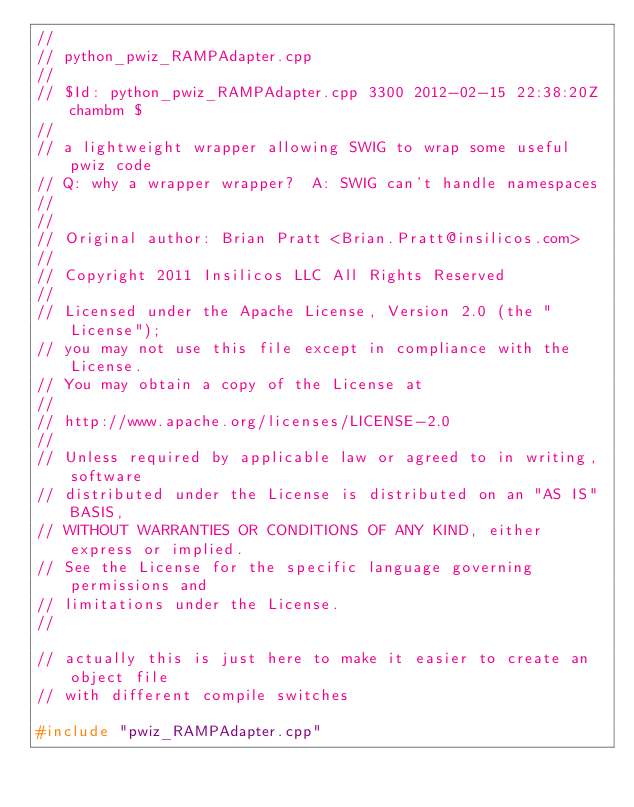<code> <loc_0><loc_0><loc_500><loc_500><_C++_>//
// python_pwiz_RAMPAdapter.cpp
//
// $Id: python_pwiz_RAMPAdapter.cpp 3300 2012-02-15 22:38:20Z chambm $
//
// a lightweight wrapper allowing SWIG to wrap some useful pwiz code
// Q: why a wrapper wrapper?  A: SWIG can't handle namespaces
//
//
// Original author: Brian Pratt <Brian.Pratt@insilicos.com>
//
// Copyright 2011 Insilicos LLC All Rights Reserved
//
// Licensed under the Apache License, Version 2.0 (the "License"); 
// you may not use this file except in compliance with the License. 
// You may obtain a copy of the License at 
//
// http://www.apache.org/licenses/LICENSE-2.0
//
// Unless required by applicable law or agreed to in writing, software 
// distributed under the License is distributed on an "AS IS" BASIS, 
// WITHOUT WARRANTIES OR CONDITIONS OF ANY KIND, either express or implied. 
// See the License for the specific language governing permissions and 
// limitations under the License.
//

// actually this is just here to make it easier to create an object file
// with different compile switches

#include "pwiz_RAMPAdapter.cpp"
</code> 